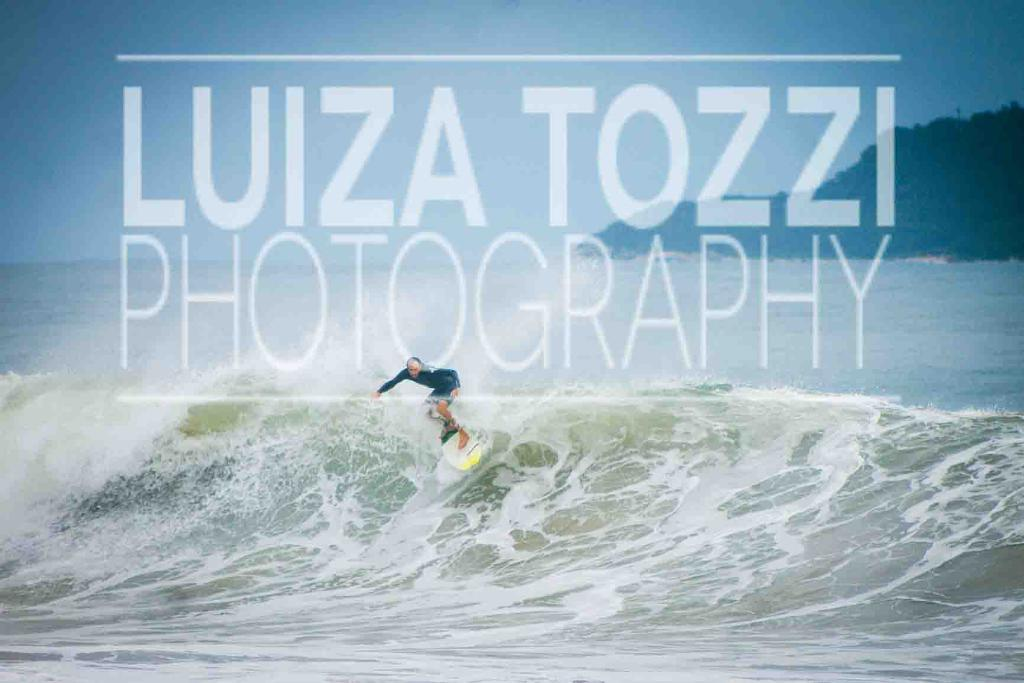What activity is the person in the image engaged in? The person is surfing in the image. Where is the person surfing? The person is in the sea. What can be seen in the background of the image? There is a mountain in the background of the image. Is there any text present in the image? Yes, there is text written on the image. What type of curtain can be seen hanging in the hall in the image? There is no curtain or hall present in the image; it features a person surfing in the sea with a mountain in the background. 